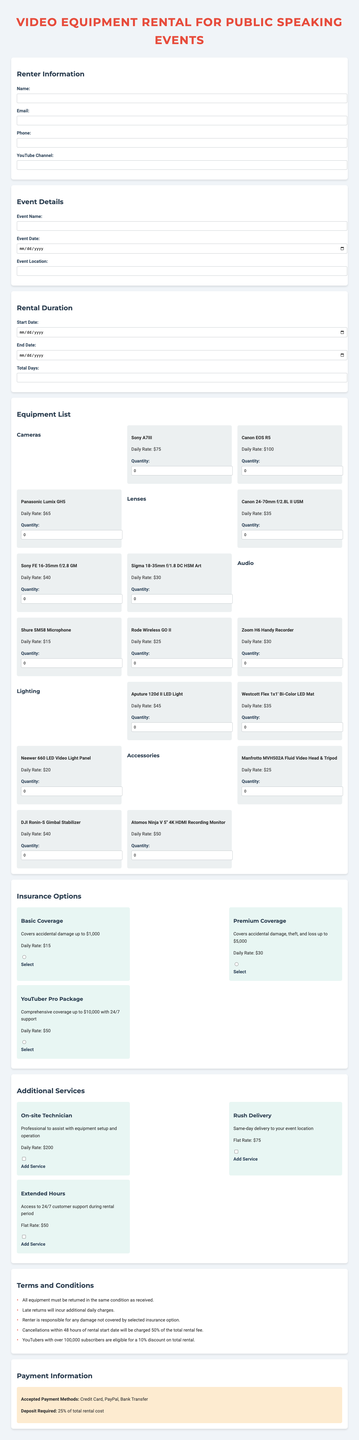what is the daily rate for the Canon EOS R5? The daily rate for the Canon EOS R5 is listed in the equipment list section of the document.
Answer: 100 how many types of insurance options are available? The insurance options section lists three distinct coverage options.
Answer: 3 what is the total deposit required for the rental? The deposit information states it is a percentage of the total rental cost quoted in the payment information section.
Answer: 25 percent which category does the Shure SM58 Microphone belong to? The microphone is part of the audio category mentioned in the equipment list section.
Answer: Audio what is the flat rate for rush delivery? This information is provided in the additional services section and specifies the cost for this specific service.
Answer: 75 which insurance option offers coverage up to $10,000? This is specified within the list of comprehensive insurance options included in the document.
Answer: YouTuber Pro Package what date format is used for the event date? The specified field for the event date uses the date picker format provided in the document's layout.
Answer: Date Picker how much will be charged for cancellations made within 48 hours? This cancellation policy outlines the specific percentage that will be forfeited if canceled late, as indicated in the terms section.
Answer: 50 percent 